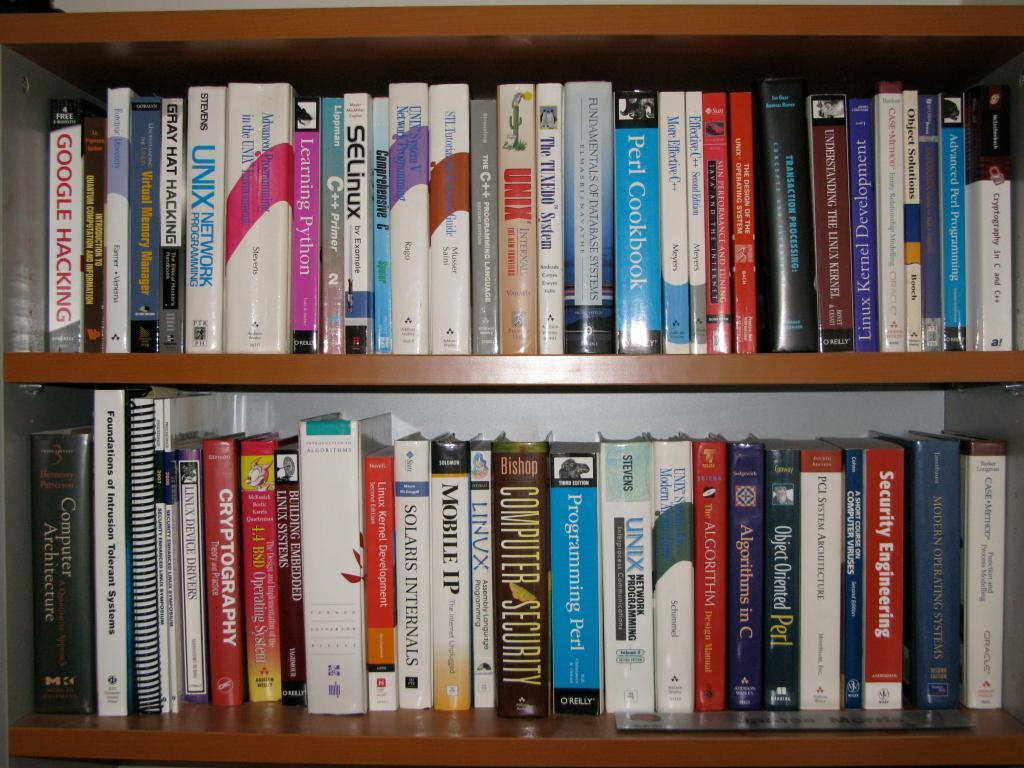Can you describe this image briefly? In the center of the image, we can see books in the shelves. 